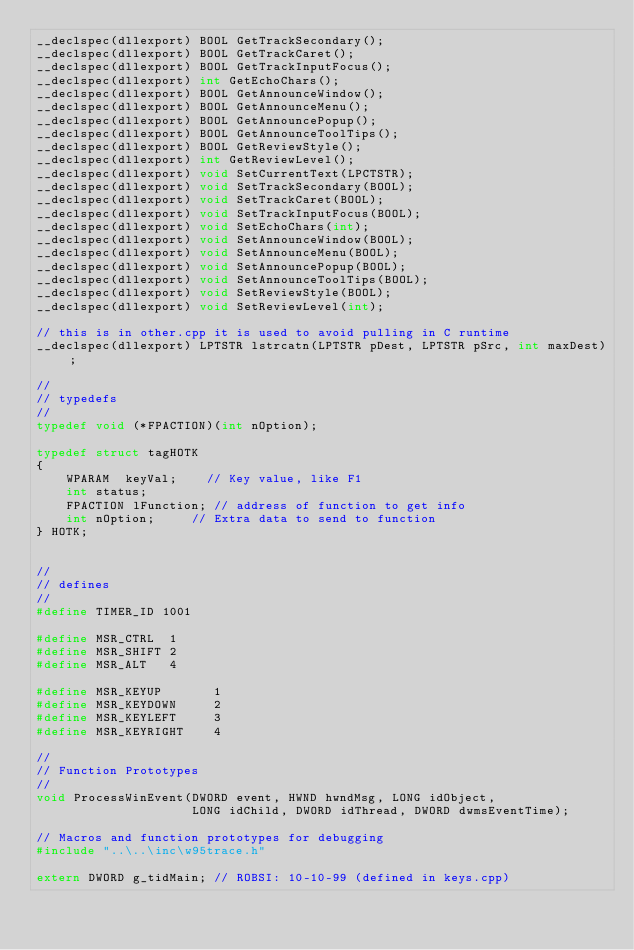Convert code to text. <code><loc_0><loc_0><loc_500><loc_500><_C_>__declspec(dllexport) BOOL GetTrackSecondary();
__declspec(dllexport) BOOL GetTrackCaret();
__declspec(dllexport) BOOL GetTrackInputFocus();
__declspec(dllexport) int GetEchoChars();
__declspec(dllexport) BOOL GetAnnounceWindow();
__declspec(dllexport) BOOL GetAnnounceMenu();
__declspec(dllexport) BOOL GetAnnouncePopup();
__declspec(dllexport) BOOL GetAnnounceToolTips();
__declspec(dllexport) BOOL GetReviewStyle();
__declspec(dllexport) int GetReviewLevel();
__declspec(dllexport) void SetCurrentText(LPCTSTR);
__declspec(dllexport) void SetTrackSecondary(BOOL);
__declspec(dllexport) void SetTrackCaret(BOOL);
__declspec(dllexport) void SetTrackInputFocus(BOOL);
__declspec(dllexport) void SetEchoChars(int);
__declspec(dllexport) void SetAnnounceWindow(BOOL);
__declspec(dllexport) void SetAnnounceMenu(BOOL);
__declspec(dllexport) void SetAnnouncePopup(BOOL);
__declspec(dllexport) void SetAnnounceToolTips(BOOL);
__declspec(dllexport) void SetReviewStyle(BOOL);
__declspec(dllexport) void SetReviewLevel(int);

// this is in other.cpp it is used to avoid pulling in C runtime
__declspec(dllexport) LPTSTR lstrcatn(LPTSTR pDest, LPTSTR pSrc, int maxDest);

//
// typedefs 
//
typedef void (*FPACTION)(int nOption);

typedef struct tagHOTK
{
    WPARAM  keyVal;    // Key value, like F1
	int status;
    FPACTION lFunction; // address of function to get info
    int nOption;     // Extra data to send to function
} HOTK;


//
// defines
//
#define TIMER_ID 1001

#define MSR_CTRL  1
#define MSR_SHIFT 2
#define MSR_ALT   4

#define MSR_KEYUP		1
#define MSR_KEYDOWN		2
#define MSR_KEYLEFT		3
#define MSR_KEYRIGHT	4

//
// Function Prototypes
//
void ProcessWinEvent(DWORD event, HWND hwndMsg, LONG idObject, 
                     LONG idChild, DWORD idThread, DWORD dwmsEventTime);

// Macros and function prototypes for debugging
#include "..\..\inc\w95trace.h"

extern DWORD g_tidMain;	// ROBSI: 10-10-99 (defined in keys.cpp)

</code> 